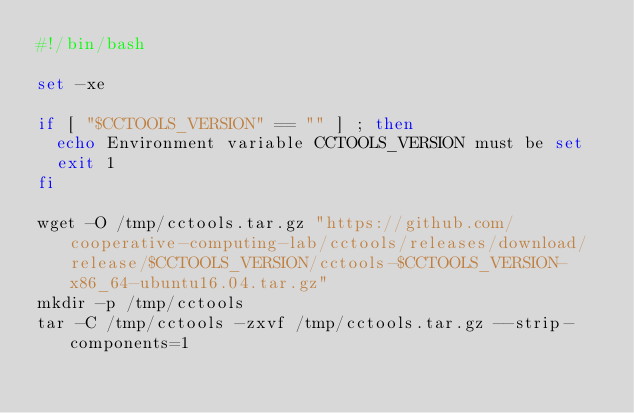Convert code to text. <code><loc_0><loc_0><loc_500><loc_500><_Bash_>#!/bin/bash

set -xe

if [ "$CCTOOLS_VERSION" == "" ] ; then
  echo Environment variable CCTOOLS_VERSION must be set
  exit 1
fi

wget -O /tmp/cctools.tar.gz "https://github.com/cooperative-computing-lab/cctools/releases/download/release/$CCTOOLS_VERSION/cctools-$CCTOOLS_VERSION-x86_64-ubuntu16.04.tar.gz"
mkdir -p /tmp/cctools
tar -C /tmp/cctools -zxvf /tmp/cctools.tar.gz --strip-components=1
</code> 